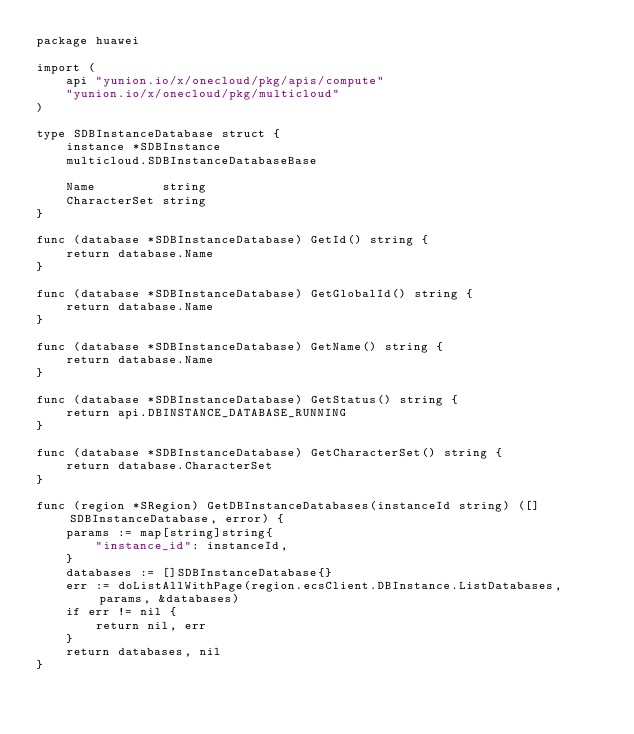<code> <loc_0><loc_0><loc_500><loc_500><_Go_>package huawei

import (
	api "yunion.io/x/onecloud/pkg/apis/compute"
	"yunion.io/x/onecloud/pkg/multicloud"
)

type SDBInstanceDatabase struct {
	instance *SDBInstance
	multicloud.SDBInstanceDatabaseBase

	Name         string
	CharacterSet string
}

func (database *SDBInstanceDatabase) GetId() string {
	return database.Name
}

func (database *SDBInstanceDatabase) GetGlobalId() string {
	return database.Name
}

func (database *SDBInstanceDatabase) GetName() string {
	return database.Name
}

func (database *SDBInstanceDatabase) GetStatus() string {
	return api.DBINSTANCE_DATABASE_RUNNING
}

func (database *SDBInstanceDatabase) GetCharacterSet() string {
	return database.CharacterSet
}

func (region *SRegion) GetDBInstanceDatabases(instanceId string) ([]SDBInstanceDatabase, error) {
	params := map[string]string{
		"instance_id": instanceId,
	}
	databases := []SDBInstanceDatabase{}
	err := doListAllWithPage(region.ecsClient.DBInstance.ListDatabases, params, &databases)
	if err != nil {
		return nil, err
	}
	return databases, nil
}
</code> 